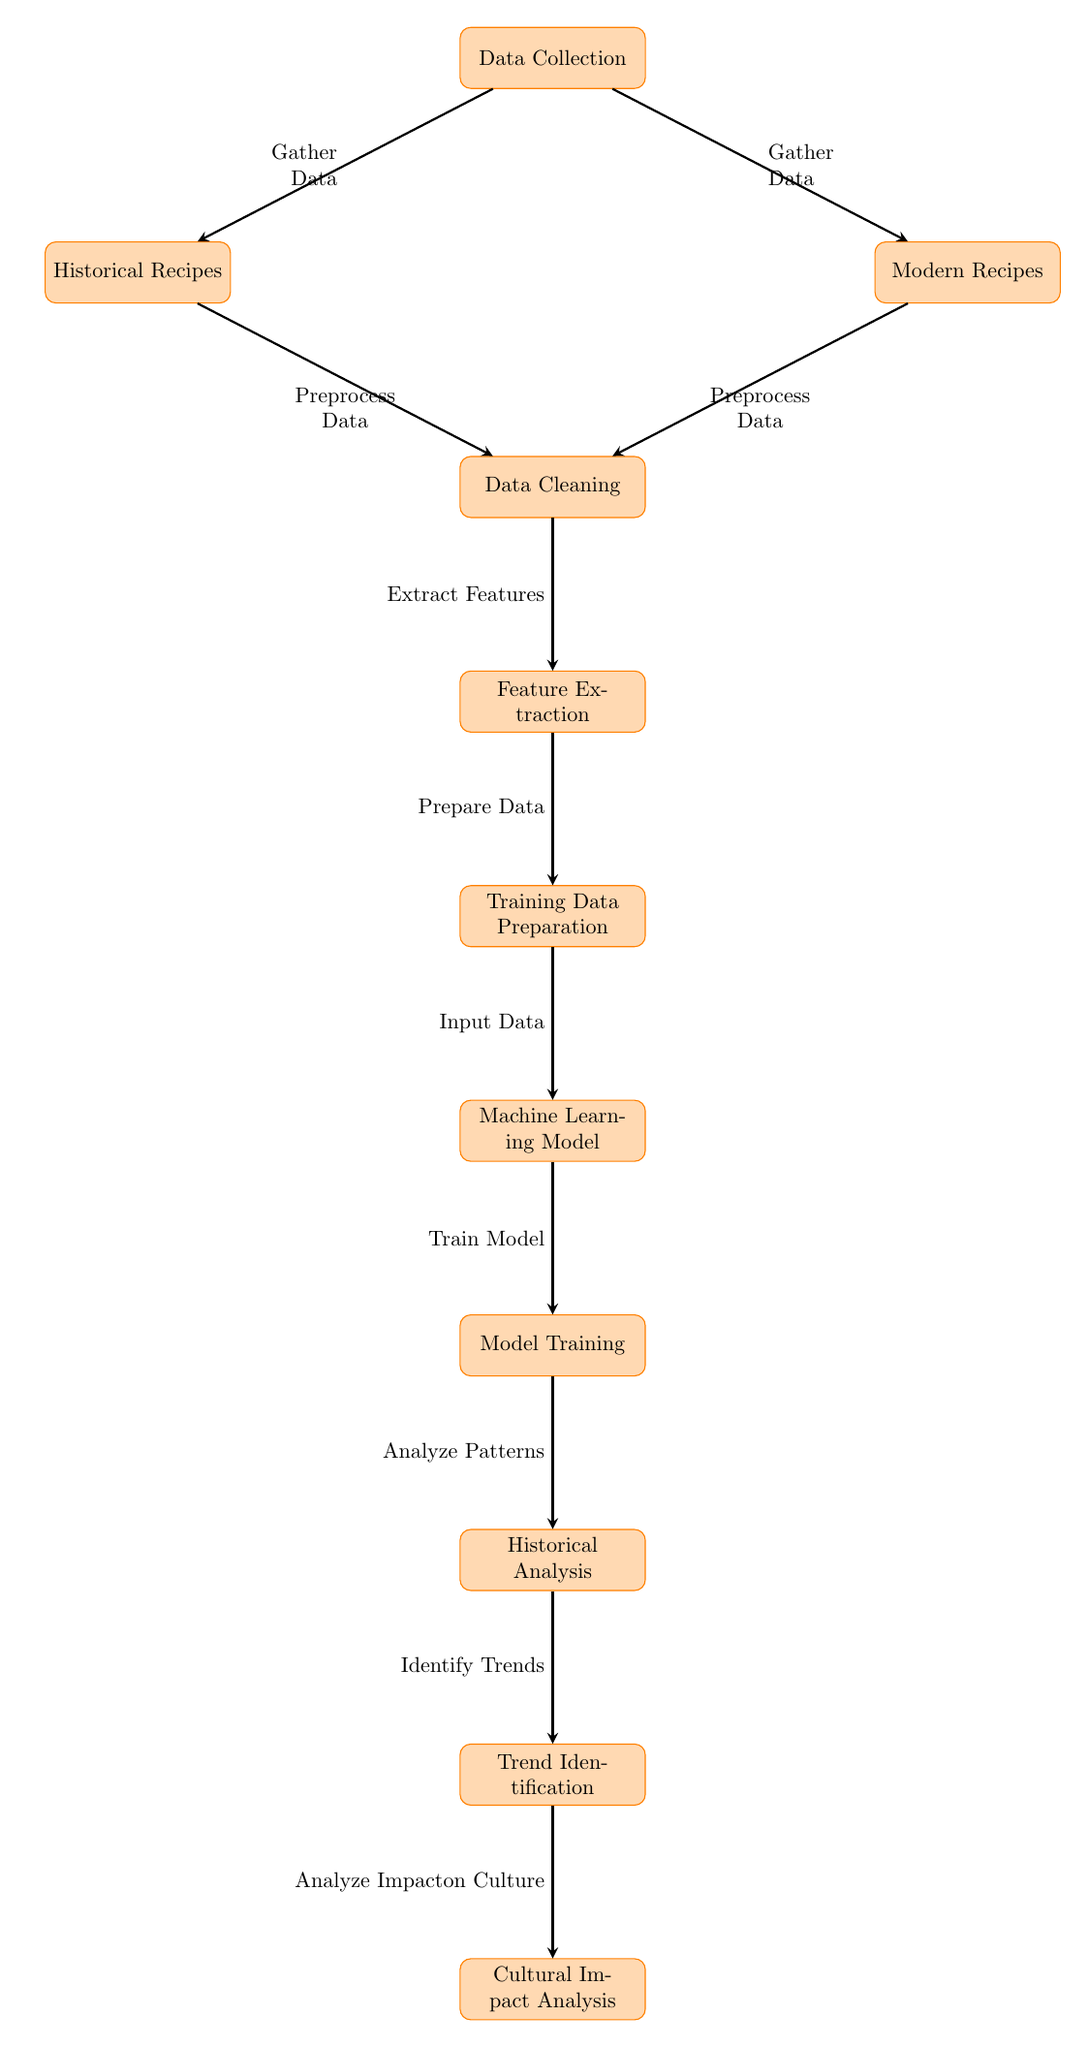What is the starting point of the diagram? The diagram begins with the "Data Collection" process, indicating that it is the initial stage where data is gathered.
Answer: Data Collection How many processes are involved in this diagram? There are a total of 10 distinct processes represented as nodes in the diagram, which illustrate various steps in analyzing Catalan baking techniques.
Answer: 10 What is the output of the "Historical Analysis" node? The output of this node leads into the "Trend Identification" node, suggesting that it is focused on uncovering historical patterns in the data with regard to baking techniques.
Answer: Trend Identification What is the action taken after "Model Training"? After the "Model Training," the action taken is "Analyze Patterns," indicating that this step involves examining the trained model's outputs to discover baking trends.
Answer: Analyze Patterns How do "Historical Recipes" and "Modern Recipes" relate to the "Data Cleaning" process? Both "Historical Recipes" and "Modern Recipes" feed into the "Data Cleaning" process, which indicates that data from these two sources is preprocessed together for further analysis.
Answer: Preprocess Data What process comes after "Feature Extraction"? The process that follows "Feature Extraction" is "Training Data Preparation," which means that once features are extracted, the next step involves organizing the data for the machine learning model.
Answer: Training Data Preparation What type of impact is analyzed at the end of the diagram? At the end of the diagram, the analysis focuses on the "Cultural Impact," which implies an examination of how the identified trends affect Catalan culture related to baking.
Answer: Cultural Impact Which node indicates a gathering of data? The "Data Collection" node indicates the gathering of data necessary for the subsequent processes, highlighting its foundational role in the workflow.
Answer: Gather Data What do the arrows represent in this diagram? The arrows represent the flow of processes in the workflow of the diagram, showing how each step is connected and proceeds to the next stage in the analysis.
Answer: The flow of processes 